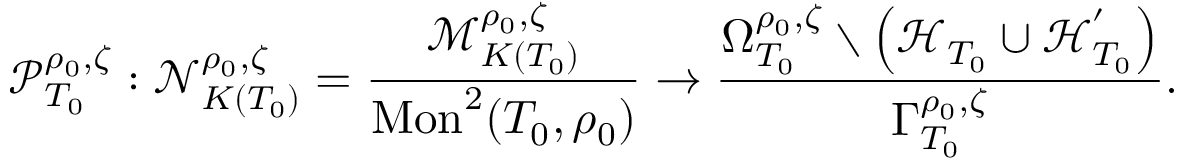Convert formula to latex. <formula><loc_0><loc_0><loc_500><loc_500>\mathcal { P } _ { T _ { 0 } } ^ { \rho _ { 0 } , \zeta } \colon \mathcal { N } _ { K ( T _ { 0 } ) } ^ { \rho _ { 0 } , \zeta } = \frac { \mathcal { M } _ { K ( T _ { 0 } ) } ^ { \rho _ { 0 } , \zeta } } { M o n ^ { 2 } ( T _ { 0 } , \rho _ { 0 } ) } \to \frac { \Omega _ { T _ { 0 } } ^ { \rho _ { 0 } , \zeta } \ \left ( \mathcal { H } _ { T _ { 0 } } \cup \mathcal { H } _ { T _ { 0 } } ^ { ^ { \prime } } \right ) } { \Gamma _ { T _ { 0 } } ^ { \rho _ { 0 } , \zeta } } .</formula> 